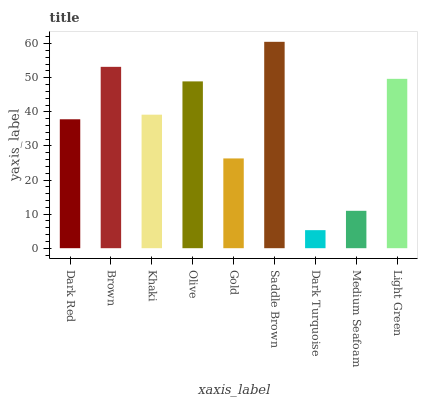Is Dark Turquoise the minimum?
Answer yes or no. Yes. Is Saddle Brown the maximum?
Answer yes or no. Yes. Is Brown the minimum?
Answer yes or no. No. Is Brown the maximum?
Answer yes or no. No. Is Brown greater than Dark Red?
Answer yes or no. Yes. Is Dark Red less than Brown?
Answer yes or no. Yes. Is Dark Red greater than Brown?
Answer yes or no. No. Is Brown less than Dark Red?
Answer yes or no. No. Is Khaki the high median?
Answer yes or no. Yes. Is Khaki the low median?
Answer yes or no. Yes. Is Brown the high median?
Answer yes or no. No. Is Gold the low median?
Answer yes or no. No. 